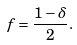Convert formula to latex. <formula><loc_0><loc_0><loc_500><loc_500>f = \frac { 1 - \delta } { 2 } .</formula> 